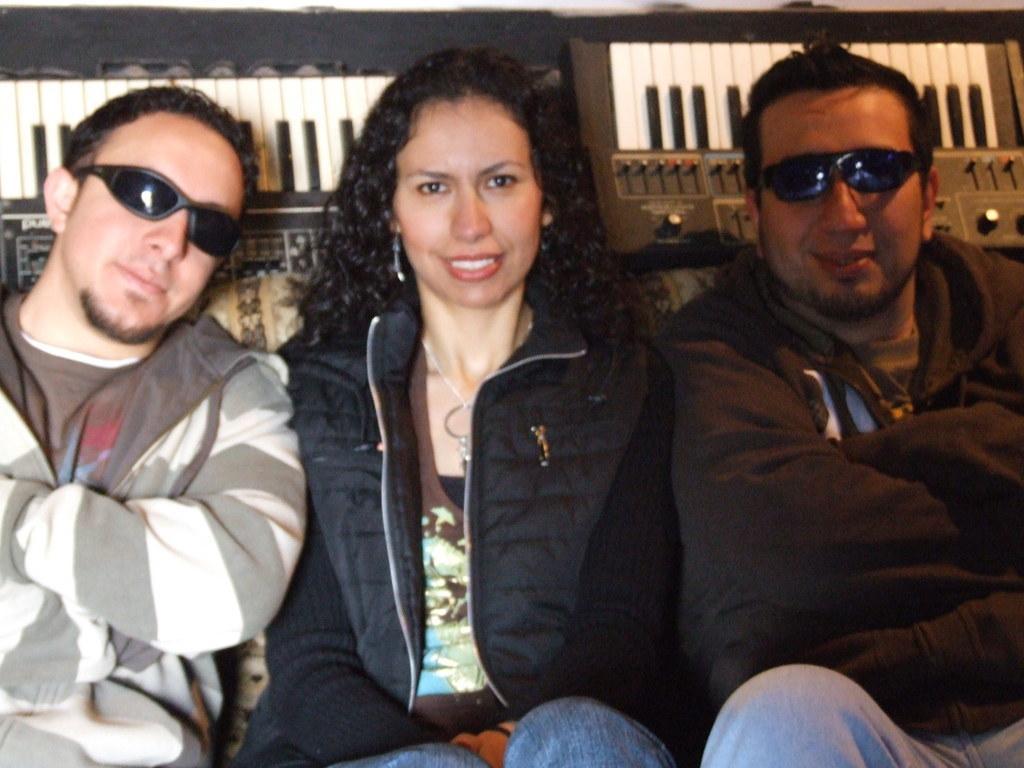Could you give a brief overview of what you see in this image? In this picture, we see three people sitting on the sofa. Three of them are smiling. Out of them, two are men and are wearing goggles and one is a woman. Behind them, we see a musical instrument which looks like a keyboard. 